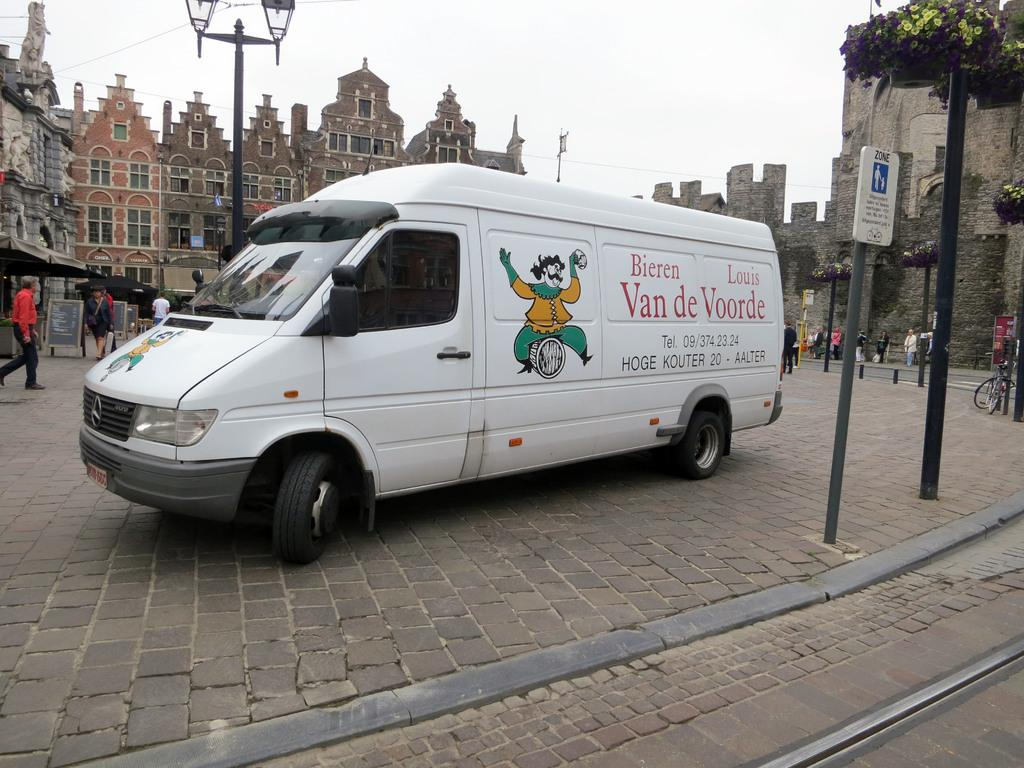<image>
Relay a brief, clear account of the picture shown. A white van which reads Bieren Louis Van de Voorde sits on a cobblestone street 